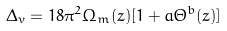<formula> <loc_0><loc_0><loc_500><loc_500>\Delta _ { v } = 1 8 \pi ^ { 2 } \Omega _ { m } ( z ) [ 1 + a \Theta ^ { b } ( z ) ]</formula> 